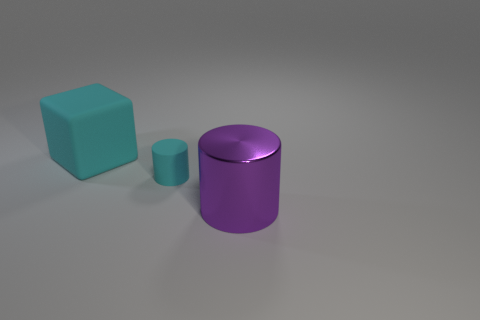How many other things are the same color as the large cube?
Keep it short and to the point. 1. Do the small matte thing and the big cube have the same color?
Ensure brevity in your answer.  Yes. What is the size of the matte object that is right of the cyan matte object that is behind the tiny cyan object?
Your answer should be very brief. Small. Is the material of the cyan thing to the left of the tiny cyan cylinder the same as the thing in front of the small thing?
Your answer should be compact. No. Does the matte object in front of the large cube have the same color as the matte block?
Make the answer very short. Yes. There is a rubber cube; how many cyan objects are right of it?
Provide a succinct answer. 1. Are the big cube and the cyan thing in front of the large rubber thing made of the same material?
Offer a very short reply. Yes. What is the size of the block that is made of the same material as the small cyan thing?
Keep it short and to the point. Large. Are there more small cylinders on the right side of the tiny cylinder than purple objects on the left side of the big purple shiny object?
Keep it short and to the point. No. Are there any cyan matte objects that have the same shape as the shiny thing?
Ensure brevity in your answer.  Yes. 